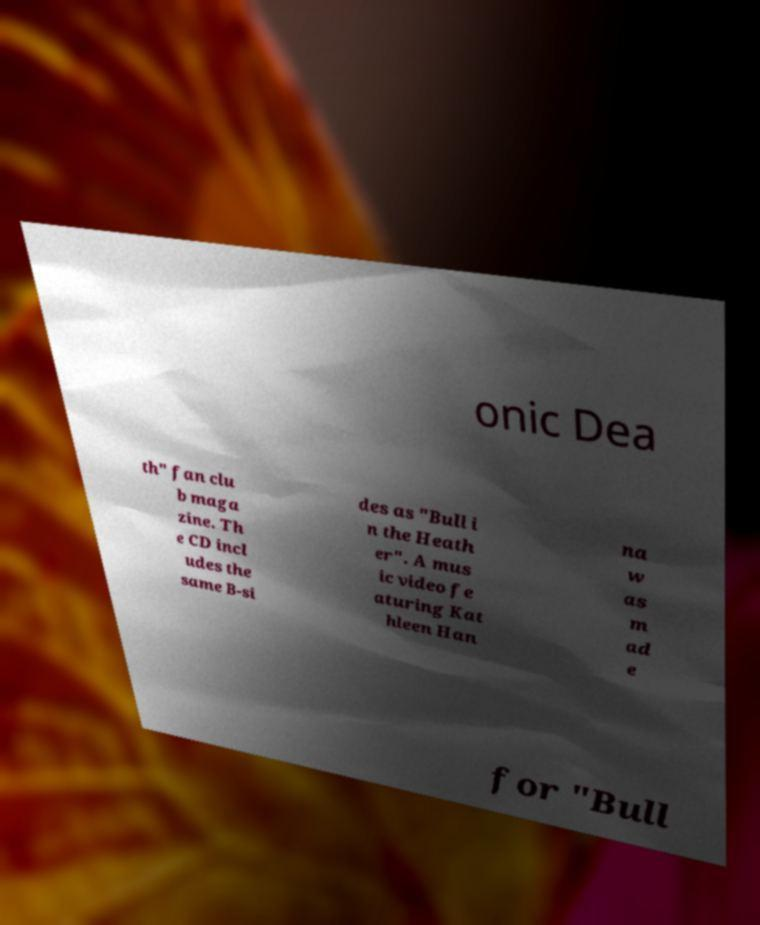Please read and relay the text visible in this image. What does it say? onic Dea th" fan clu b maga zine. Th e CD incl udes the same B-si des as "Bull i n the Heath er". A mus ic video fe aturing Kat hleen Han na w as m ad e for "Bull 